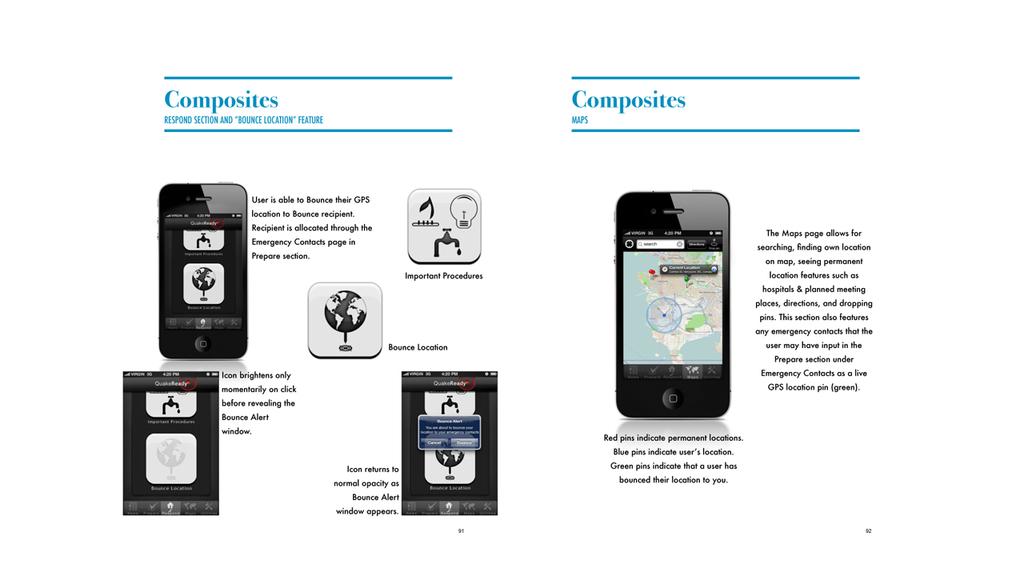Can we bounce our gps location?
Provide a short and direct response. Yes. What does the big word say on the top in between the blue lines?
Provide a succinct answer. Composites. 